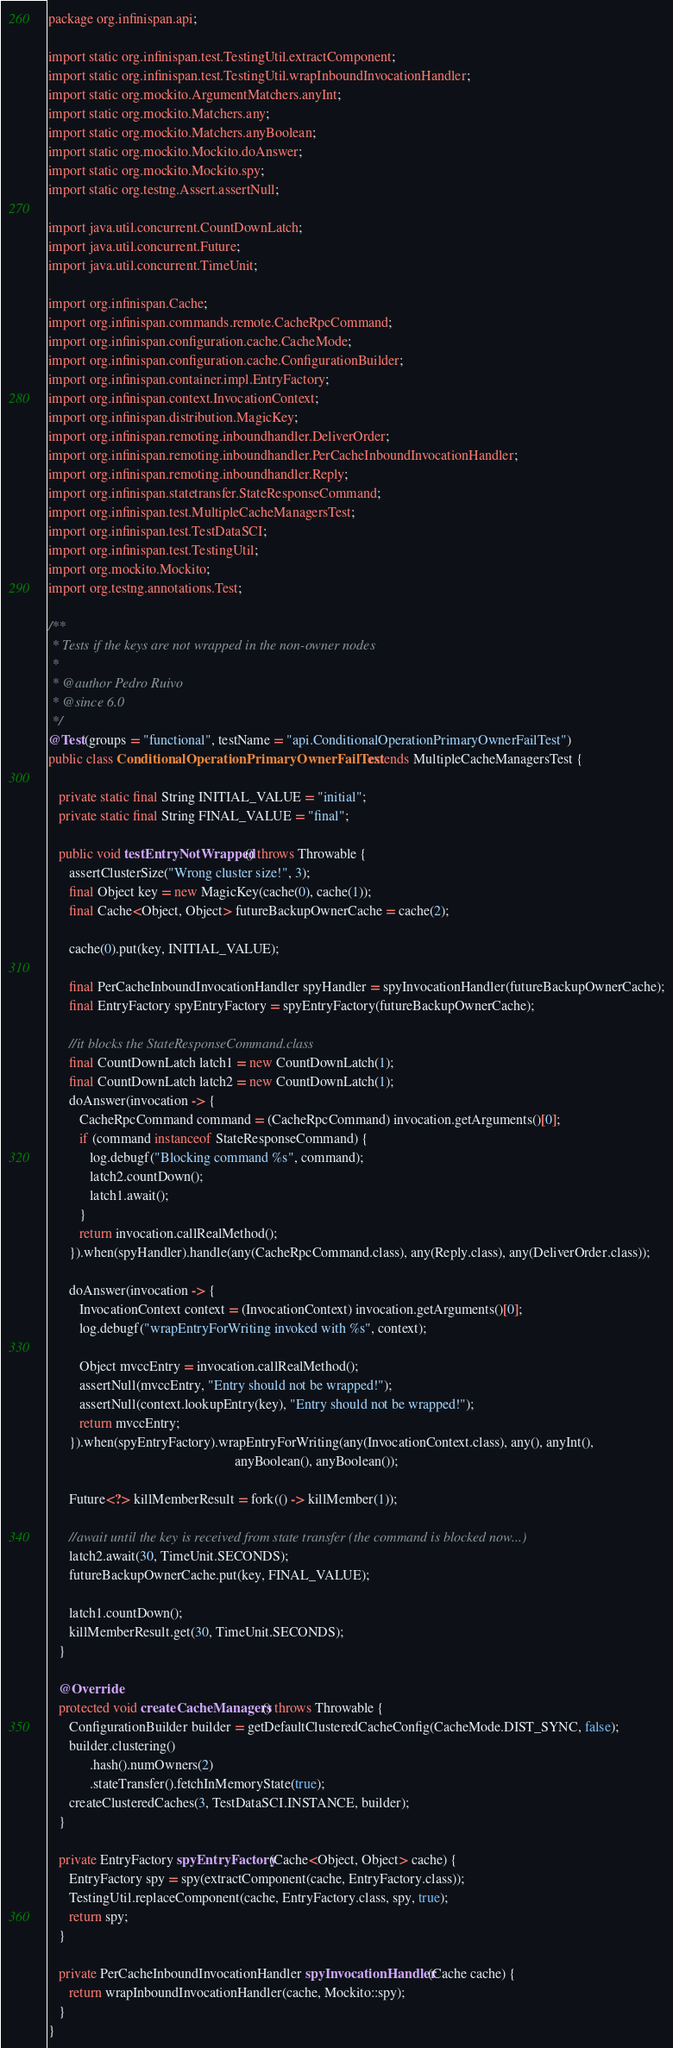<code> <loc_0><loc_0><loc_500><loc_500><_Java_>package org.infinispan.api;

import static org.infinispan.test.TestingUtil.extractComponent;
import static org.infinispan.test.TestingUtil.wrapInboundInvocationHandler;
import static org.mockito.ArgumentMatchers.anyInt;
import static org.mockito.Matchers.any;
import static org.mockito.Matchers.anyBoolean;
import static org.mockito.Mockito.doAnswer;
import static org.mockito.Mockito.spy;
import static org.testng.Assert.assertNull;

import java.util.concurrent.CountDownLatch;
import java.util.concurrent.Future;
import java.util.concurrent.TimeUnit;

import org.infinispan.Cache;
import org.infinispan.commands.remote.CacheRpcCommand;
import org.infinispan.configuration.cache.CacheMode;
import org.infinispan.configuration.cache.ConfigurationBuilder;
import org.infinispan.container.impl.EntryFactory;
import org.infinispan.context.InvocationContext;
import org.infinispan.distribution.MagicKey;
import org.infinispan.remoting.inboundhandler.DeliverOrder;
import org.infinispan.remoting.inboundhandler.PerCacheInboundInvocationHandler;
import org.infinispan.remoting.inboundhandler.Reply;
import org.infinispan.statetransfer.StateResponseCommand;
import org.infinispan.test.MultipleCacheManagersTest;
import org.infinispan.test.TestDataSCI;
import org.infinispan.test.TestingUtil;
import org.mockito.Mockito;
import org.testng.annotations.Test;

/**
 * Tests if the keys are not wrapped in the non-owner nodes
 *
 * @author Pedro Ruivo
 * @since 6.0
 */
@Test(groups = "functional", testName = "api.ConditionalOperationPrimaryOwnerFailTest")
public class ConditionalOperationPrimaryOwnerFailTest extends MultipleCacheManagersTest {

   private static final String INITIAL_VALUE = "initial";
   private static final String FINAL_VALUE = "final";

   public void testEntryNotWrapped() throws Throwable {
      assertClusterSize("Wrong cluster size!", 3);
      final Object key = new MagicKey(cache(0), cache(1));
      final Cache<Object, Object> futureBackupOwnerCache = cache(2);

      cache(0).put(key, INITIAL_VALUE);

      final PerCacheInboundInvocationHandler spyHandler = spyInvocationHandler(futureBackupOwnerCache);
      final EntryFactory spyEntryFactory = spyEntryFactory(futureBackupOwnerCache);

      //it blocks the StateResponseCommand.class
      final CountDownLatch latch1 = new CountDownLatch(1);
      final CountDownLatch latch2 = new CountDownLatch(1);
      doAnswer(invocation -> {
         CacheRpcCommand command = (CacheRpcCommand) invocation.getArguments()[0];
         if (command instanceof StateResponseCommand) {
            log.debugf("Blocking command %s", command);
            latch2.countDown();
            latch1.await();
         }
         return invocation.callRealMethod();
      }).when(spyHandler).handle(any(CacheRpcCommand.class), any(Reply.class), any(DeliverOrder.class));

      doAnswer(invocation -> {
         InvocationContext context = (InvocationContext) invocation.getArguments()[0];
         log.debugf("wrapEntryForWriting invoked with %s", context);

         Object mvccEntry = invocation.callRealMethod();
         assertNull(mvccEntry, "Entry should not be wrapped!");
         assertNull(context.lookupEntry(key), "Entry should not be wrapped!");
         return mvccEntry;
      }).when(spyEntryFactory).wrapEntryForWriting(any(InvocationContext.class), any(), anyInt(),
                                                      anyBoolean(), anyBoolean());

      Future<?> killMemberResult = fork(() -> killMember(1));

      //await until the key is received from state transfer (the command is blocked now...)
      latch2.await(30, TimeUnit.SECONDS);
      futureBackupOwnerCache.put(key, FINAL_VALUE);

      latch1.countDown();
      killMemberResult.get(30, TimeUnit.SECONDS);
   }

   @Override
   protected void createCacheManagers() throws Throwable {
      ConfigurationBuilder builder = getDefaultClusteredCacheConfig(CacheMode.DIST_SYNC, false);
      builder.clustering()
            .hash().numOwners(2)
            .stateTransfer().fetchInMemoryState(true);
      createClusteredCaches(3, TestDataSCI.INSTANCE, builder);
   }

   private EntryFactory spyEntryFactory(Cache<Object, Object> cache) {
      EntryFactory spy = spy(extractComponent(cache, EntryFactory.class));
      TestingUtil.replaceComponent(cache, EntryFactory.class, spy, true);
      return spy;
   }

   private PerCacheInboundInvocationHandler spyInvocationHandler(Cache cache) {
      return wrapInboundInvocationHandler(cache, Mockito::spy);
   }
}
</code> 